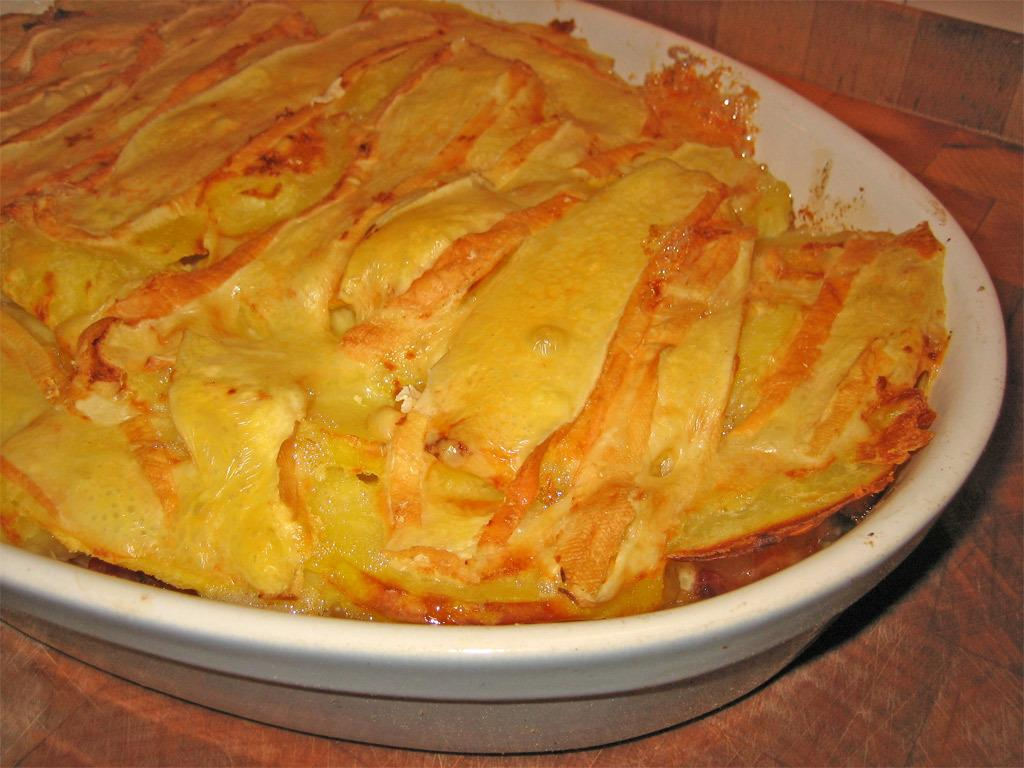What object is present on the floor in the image? There is a tray on the floor in the image. What is the color of the tray? The tray is white in color. What can be found on top of the tray? There are food items on the tray. What type of battle is taking place in the image? There is no battle present in the image; it only features a white tray with food items on it. How many tomatoes are visible on the tray? There is no mention of tomatoes in the image; only food items are mentioned. 